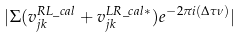<formula> <loc_0><loc_0><loc_500><loc_500>| \Sigma ( v _ { j k } ^ { R L \_ c a l } + { { v _ { j k } ^ { L R \_ c a l * } } ) e ^ { - 2 \pi i ( \Delta \tau \nu ) } } |</formula> 